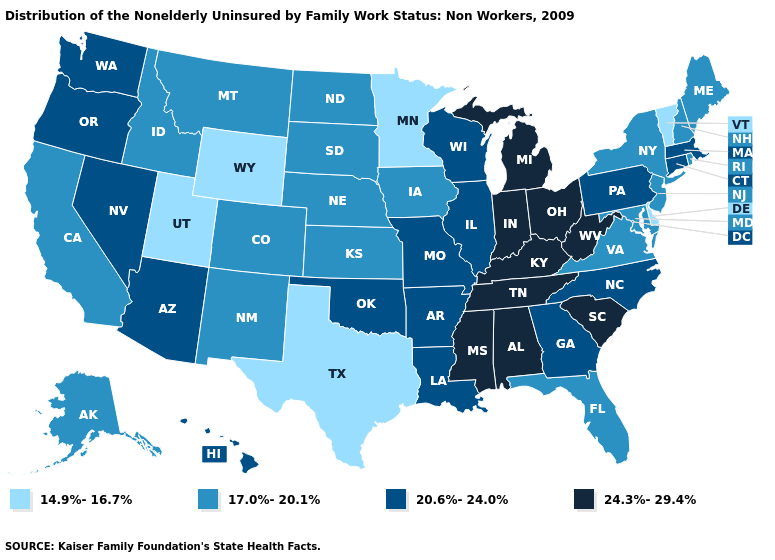Does Louisiana have the lowest value in the USA?
Be succinct. No. Does New Hampshire have the lowest value in the Northeast?
Keep it brief. No. Among the states that border Iowa , does Minnesota have the lowest value?
Give a very brief answer. Yes. Does the map have missing data?
Quick response, please. No. Does Oregon have the lowest value in the West?
Short answer required. No. Is the legend a continuous bar?
Concise answer only. No. What is the value of Washington?
Quick response, please. 20.6%-24.0%. Does Michigan have the lowest value in the USA?
Answer briefly. No. Name the states that have a value in the range 14.9%-16.7%?
Quick response, please. Delaware, Minnesota, Texas, Utah, Vermont, Wyoming. Does Florida have the same value as Alabama?
Concise answer only. No. Name the states that have a value in the range 17.0%-20.1%?
Be succinct. Alaska, California, Colorado, Florida, Idaho, Iowa, Kansas, Maine, Maryland, Montana, Nebraska, New Hampshire, New Jersey, New Mexico, New York, North Dakota, Rhode Island, South Dakota, Virginia. Among the states that border Kansas , does Oklahoma have the highest value?
Quick response, please. Yes. Does Georgia have a lower value than Louisiana?
Quick response, please. No. Does North Dakota have the same value as Michigan?
Write a very short answer. No. What is the highest value in states that border Wisconsin?
Write a very short answer. 24.3%-29.4%. 